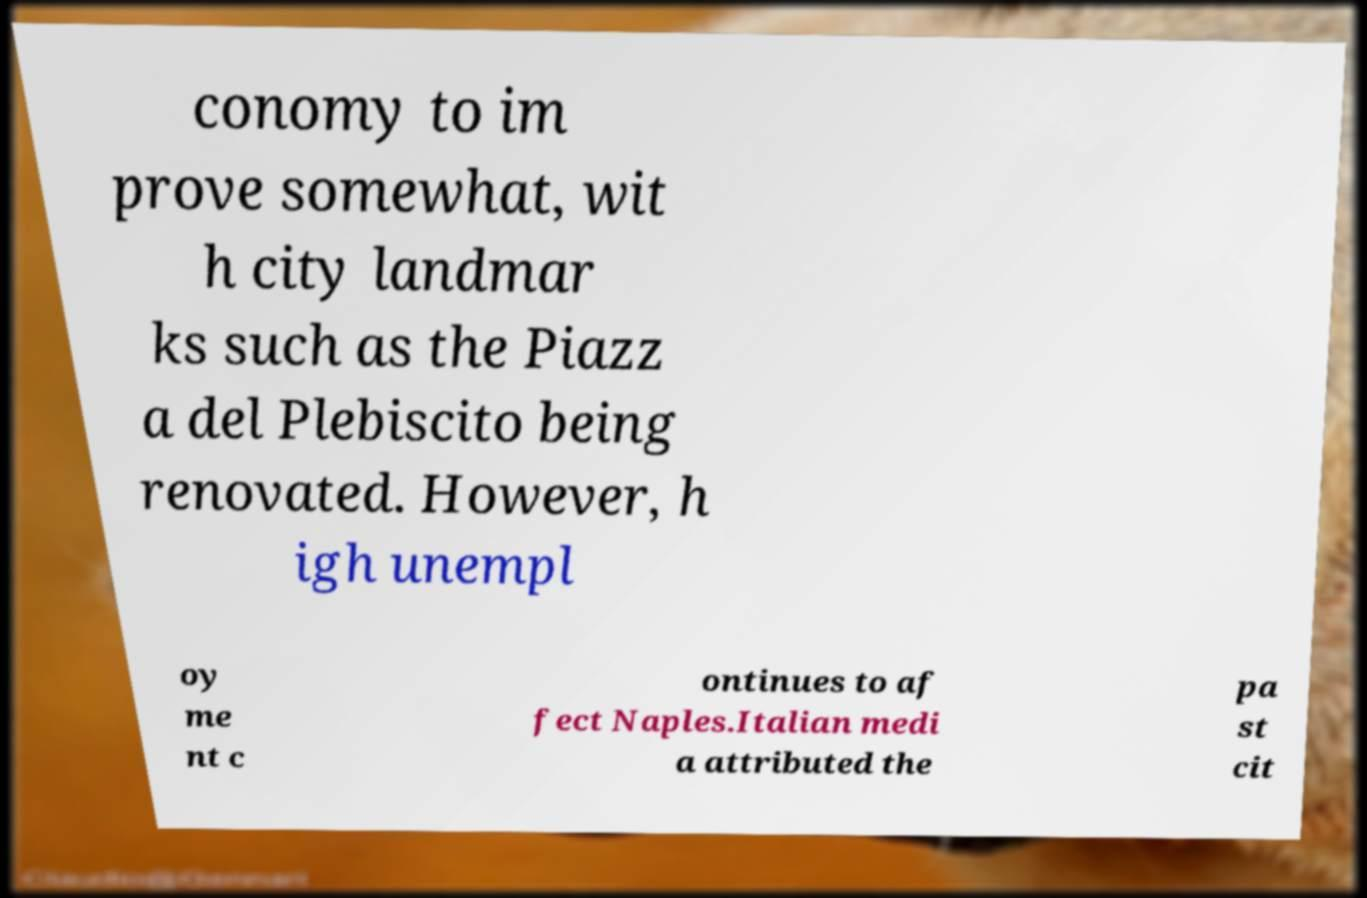Can you accurately transcribe the text from the provided image for me? conomy to im prove somewhat, wit h city landmar ks such as the Piazz a del Plebiscito being renovated. However, h igh unempl oy me nt c ontinues to af fect Naples.Italian medi a attributed the pa st cit 